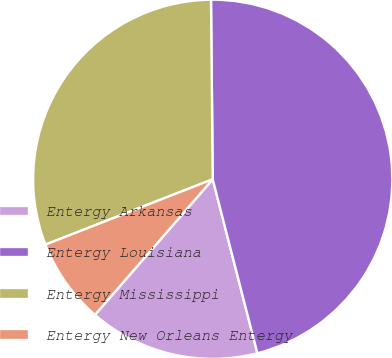<chart> <loc_0><loc_0><loc_500><loc_500><pie_chart><fcel>Entergy Arkansas<fcel>Entergy Louisiana<fcel>Entergy Mississippi<fcel>Entergy New Orleans Entergy<nl><fcel>15.38%<fcel>46.15%<fcel>30.77%<fcel>7.69%<nl></chart> 